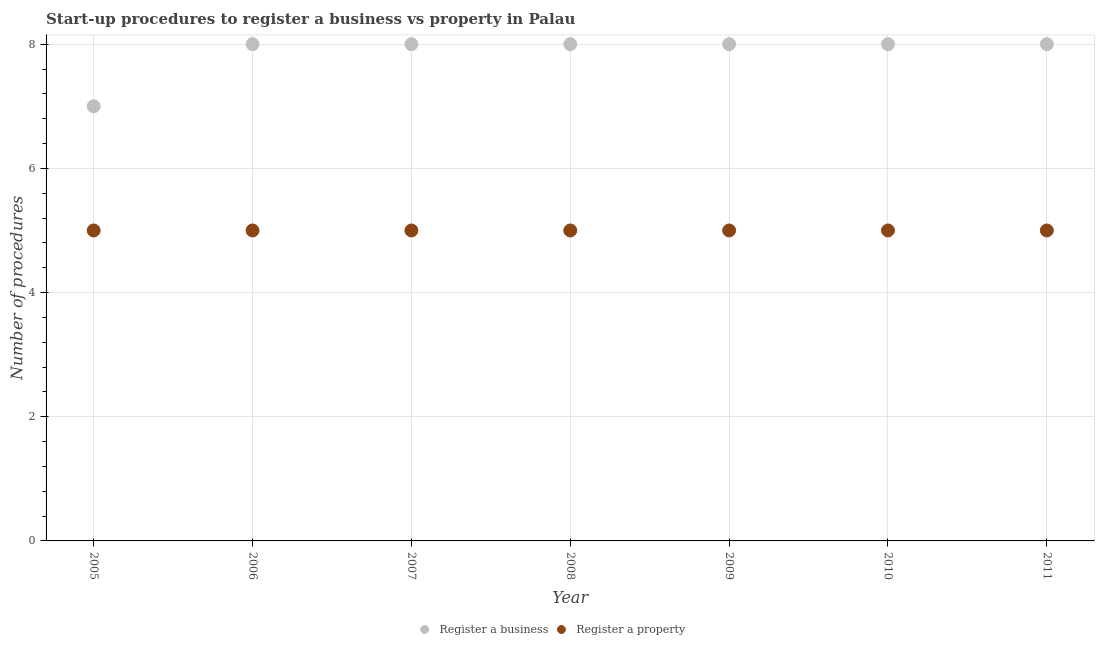What is the number of procedures to register a property in 2006?
Keep it short and to the point. 5. Across all years, what is the maximum number of procedures to register a property?
Offer a very short reply. 5. Across all years, what is the minimum number of procedures to register a property?
Your answer should be compact. 5. What is the total number of procedures to register a business in the graph?
Make the answer very short. 55. What is the difference between the number of procedures to register a property in 2011 and the number of procedures to register a business in 2008?
Make the answer very short. -3. What is the average number of procedures to register a business per year?
Offer a terse response. 7.86. In the year 2005, what is the difference between the number of procedures to register a business and number of procedures to register a property?
Offer a terse response. 2. What is the ratio of the number of procedures to register a property in 2007 to that in 2008?
Keep it short and to the point. 1. Is the number of procedures to register a property in 2005 less than that in 2006?
Your answer should be very brief. No. What is the difference between the highest and the second highest number of procedures to register a business?
Provide a short and direct response. 0. What is the difference between the highest and the lowest number of procedures to register a business?
Give a very brief answer. 1. In how many years, is the number of procedures to register a property greater than the average number of procedures to register a property taken over all years?
Keep it short and to the point. 0. Is the sum of the number of procedures to register a business in 2006 and 2011 greater than the maximum number of procedures to register a property across all years?
Make the answer very short. Yes. Does the number of procedures to register a property monotonically increase over the years?
Provide a succinct answer. No. Is the number of procedures to register a business strictly greater than the number of procedures to register a property over the years?
Give a very brief answer. Yes. Is the number of procedures to register a business strictly less than the number of procedures to register a property over the years?
Provide a short and direct response. No. How many dotlines are there?
Make the answer very short. 2. What is the difference between two consecutive major ticks on the Y-axis?
Offer a terse response. 2. Does the graph contain any zero values?
Your answer should be compact. No. Where does the legend appear in the graph?
Your answer should be compact. Bottom center. What is the title of the graph?
Your answer should be compact. Start-up procedures to register a business vs property in Palau. Does "Urban Population" appear as one of the legend labels in the graph?
Give a very brief answer. No. What is the label or title of the X-axis?
Your response must be concise. Year. What is the label or title of the Y-axis?
Provide a short and direct response. Number of procedures. What is the Number of procedures in Register a business in 2005?
Provide a succinct answer. 7. What is the Number of procedures in Register a property in 2006?
Keep it short and to the point. 5. What is the Number of procedures in Register a property in 2007?
Make the answer very short. 5. What is the Number of procedures of Register a business in 2008?
Provide a succinct answer. 8. What is the Number of procedures of Register a business in 2011?
Ensure brevity in your answer.  8. What is the Number of procedures in Register a property in 2011?
Give a very brief answer. 5. Across all years, what is the minimum Number of procedures in Register a property?
Provide a short and direct response. 5. What is the difference between the Number of procedures in Register a property in 2005 and that in 2006?
Your response must be concise. 0. What is the difference between the Number of procedures in Register a business in 2005 and that in 2009?
Your response must be concise. -1. What is the difference between the Number of procedures in Register a business in 2005 and that in 2010?
Give a very brief answer. -1. What is the difference between the Number of procedures of Register a property in 2005 and that in 2010?
Ensure brevity in your answer.  0. What is the difference between the Number of procedures in Register a property in 2005 and that in 2011?
Keep it short and to the point. 0. What is the difference between the Number of procedures in Register a business in 2006 and that in 2007?
Your response must be concise. 0. What is the difference between the Number of procedures in Register a property in 2006 and that in 2007?
Give a very brief answer. 0. What is the difference between the Number of procedures in Register a business in 2006 and that in 2009?
Keep it short and to the point. 0. What is the difference between the Number of procedures of Register a property in 2006 and that in 2009?
Provide a short and direct response. 0. What is the difference between the Number of procedures in Register a business in 2006 and that in 2011?
Your answer should be very brief. 0. What is the difference between the Number of procedures in Register a property in 2006 and that in 2011?
Offer a terse response. 0. What is the difference between the Number of procedures in Register a business in 2007 and that in 2008?
Provide a succinct answer. 0. What is the difference between the Number of procedures in Register a business in 2007 and that in 2009?
Your response must be concise. 0. What is the difference between the Number of procedures in Register a business in 2007 and that in 2010?
Make the answer very short. 0. What is the difference between the Number of procedures in Register a business in 2008 and that in 2009?
Provide a short and direct response. 0. What is the difference between the Number of procedures in Register a business in 2008 and that in 2011?
Your answer should be compact. 0. What is the difference between the Number of procedures of Register a business in 2009 and that in 2010?
Keep it short and to the point. 0. What is the difference between the Number of procedures of Register a property in 2009 and that in 2010?
Your answer should be compact. 0. What is the difference between the Number of procedures of Register a business in 2009 and that in 2011?
Offer a terse response. 0. What is the difference between the Number of procedures of Register a property in 2009 and that in 2011?
Your response must be concise. 0. What is the difference between the Number of procedures of Register a business in 2005 and the Number of procedures of Register a property in 2006?
Your answer should be compact. 2. What is the difference between the Number of procedures of Register a business in 2005 and the Number of procedures of Register a property in 2007?
Offer a terse response. 2. What is the difference between the Number of procedures of Register a business in 2005 and the Number of procedures of Register a property in 2009?
Your answer should be compact. 2. What is the difference between the Number of procedures of Register a business in 2005 and the Number of procedures of Register a property in 2011?
Offer a terse response. 2. What is the difference between the Number of procedures in Register a business in 2006 and the Number of procedures in Register a property in 2008?
Keep it short and to the point. 3. What is the difference between the Number of procedures in Register a business in 2006 and the Number of procedures in Register a property in 2010?
Offer a very short reply. 3. What is the difference between the Number of procedures in Register a business in 2007 and the Number of procedures in Register a property in 2008?
Provide a succinct answer. 3. What is the difference between the Number of procedures in Register a business in 2007 and the Number of procedures in Register a property in 2011?
Your answer should be compact. 3. What is the difference between the Number of procedures of Register a business in 2008 and the Number of procedures of Register a property in 2010?
Provide a succinct answer. 3. What is the difference between the Number of procedures in Register a business in 2008 and the Number of procedures in Register a property in 2011?
Your answer should be very brief. 3. What is the difference between the Number of procedures in Register a business in 2009 and the Number of procedures in Register a property in 2011?
Your answer should be very brief. 3. What is the difference between the Number of procedures in Register a business in 2010 and the Number of procedures in Register a property in 2011?
Offer a terse response. 3. What is the average Number of procedures of Register a business per year?
Your answer should be very brief. 7.86. What is the average Number of procedures in Register a property per year?
Your response must be concise. 5. In the year 2006, what is the difference between the Number of procedures in Register a business and Number of procedures in Register a property?
Offer a very short reply. 3. In the year 2008, what is the difference between the Number of procedures in Register a business and Number of procedures in Register a property?
Give a very brief answer. 3. In the year 2010, what is the difference between the Number of procedures in Register a business and Number of procedures in Register a property?
Your answer should be very brief. 3. In the year 2011, what is the difference between the Number of procedures of Register a business and Number of procedures of Register a property?
Provide a short and direct response. 3. What is the ratio of the Number of procedures of Register a business in 2005 to that in 2006?
Your answer should be compact. 0.88. What is the ratio of the Number of procedures of Register a business in 2005 to that in 2007?
Offer a very short reply. 0.88. What is the ratio of the Number of procedures in Register a property in 2005 to that in 2008?
Provide a short and direct response. 1. What is the ratio of the Number of procedures of Register a property in 2005 to that in 2009?
Give a very brief answer. 1. What is the ratio of the Number of procedures of Register a business in 2005 to that in 2010?
Make the answer very short. 0.88. What is the ratio of the Number of procedures of Register a business in 2005 to that in 2011?
Offer a terse response. 0.88. What is the ratio of the Number of procedures of Register a business in 2006 to that in 2007?
Your response must be concise. 1. What is the ratio of the Number of procedures in Register a business in 2006 to that in 2008?
Provide a succinct answer. 1. What is the ratio of the Number of procedures in Register a property in 2006 to that in 2009?
Your answer should be very brief. 1. What is the ratio of the Number of procedures in Register a property in 2006 to that in 2010?
Your answer should be very brief. 1. What is the ratio of the Number of procedures in Register a business in 2006 to that in 2011?
Offer a very short reply. 1. What is the ratio of the Number of procedures in Register a property in 2006 to that in 2011?
Your answer should be very brief. 1. What is the ratio of the Number of procedures of Register a business in 2007 to that in 2008?
Your answer should be very brief. 1. What is the ratio of the Number of procedures of Register a property in 2007 to that in 2009?
Offer a very short reply. 1. What is the ratio of the Number of procedures in Register a property in 2007 to that in 2010?
Your answer should be compact. 1. What is the ratio of the Number of procedures in Register a business in 2007 to that in 2011?
Provide a succinct answer. 1. What is the ratio of the Number of procedures in Register a property in 2007 to that in 2011?
Provide a short and direct response. 1. What is the ratio of the Number of procedures in Register a business in 2008 to that in 2009?
Your response must be concise. 1. What is the ratio of the Number of procedures in Register a property in 2008 to that in 2009?
Offer a very short reply. 1. What is the ratio of the Number of procedures of Register a business in 2008 to that in 2010?
Your answer should be very brief. 1. What is the ratio of the Number of procedures of Register a property in 2008 to that in 2010?
Make the answer very short. 1. What is the ratio of the Number of procedures in Register a property in 2008 to that in 2011?
Provide a succinct answer. 1. What is the ratio of the Number of procedures of Register a business in 2009 to that in 2011?
Offer a very short reply. 1. What is the ratio of the Number of procedures in Register a property in 2010 to that in 2011?
Make the answer very short. 1. 